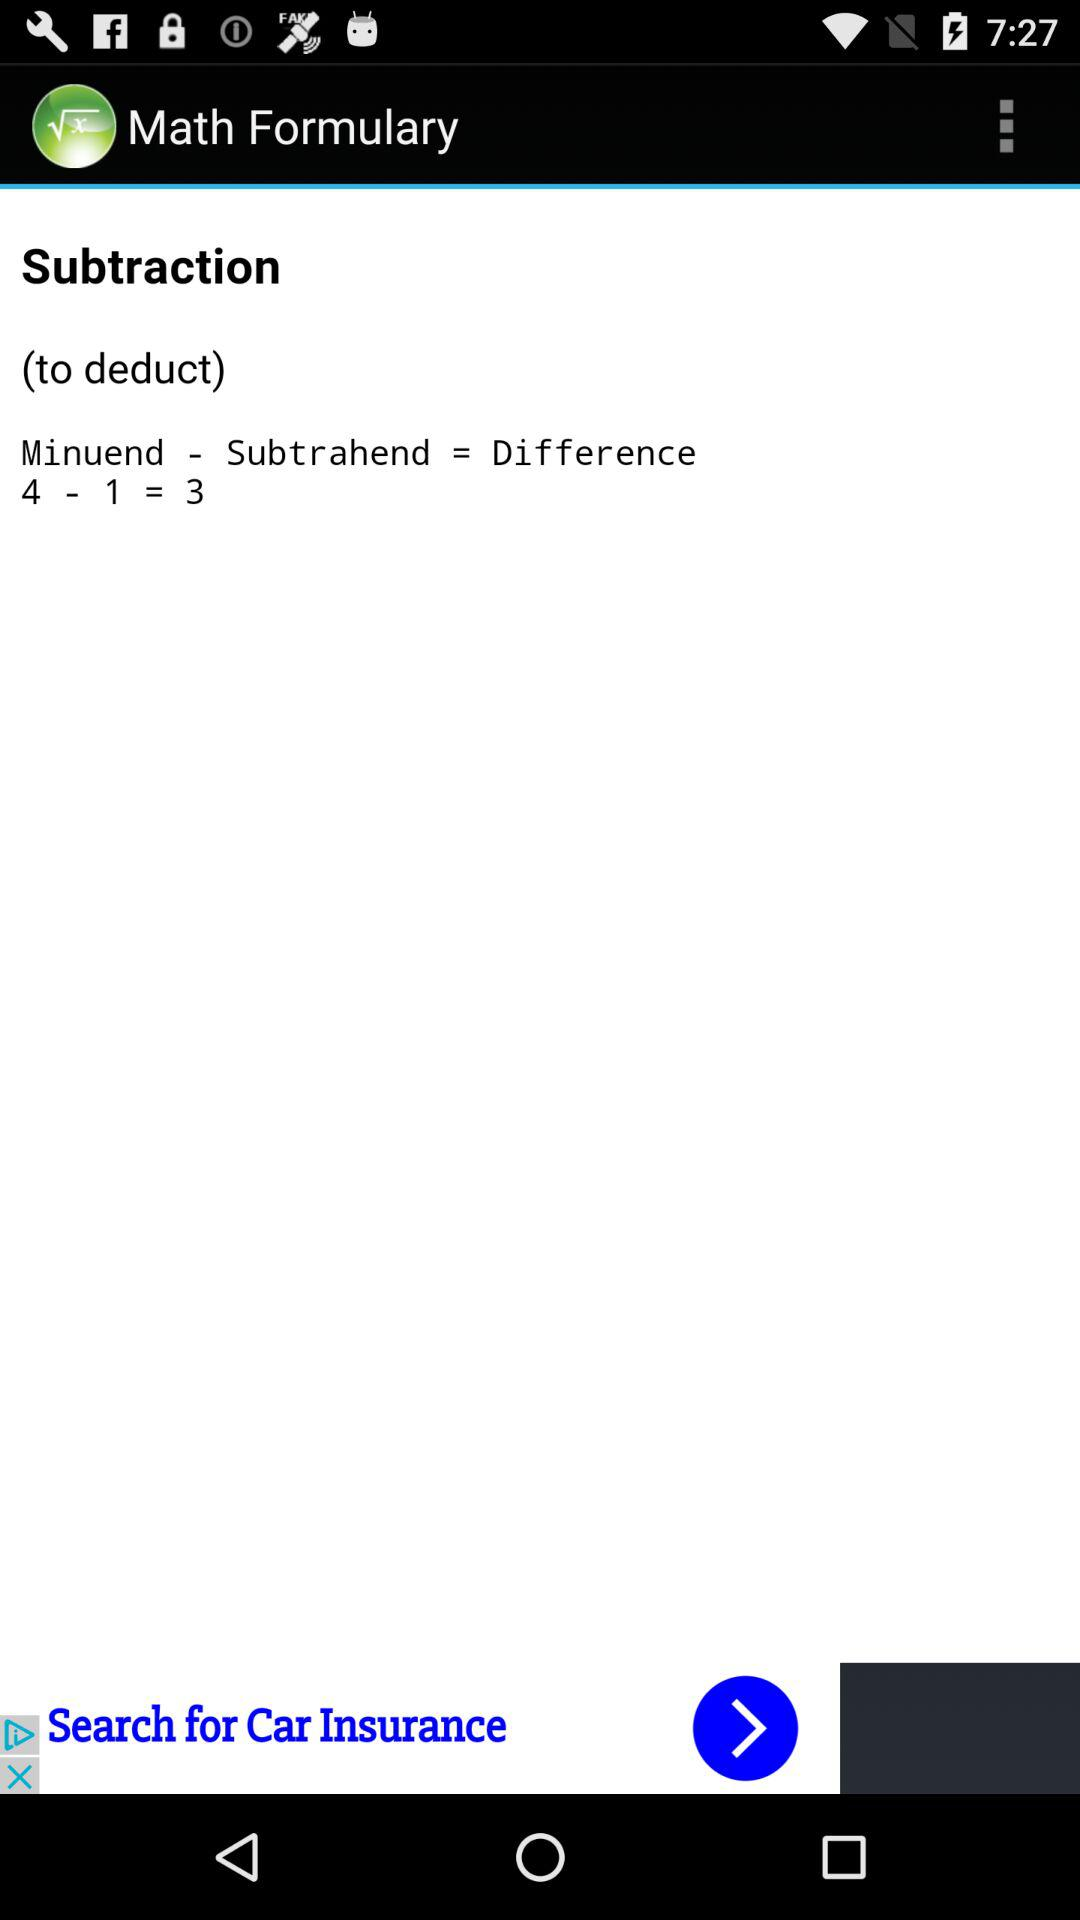What is the difference between the minuend and subtrahend?
Answer the question using a single word or phrase. 3 